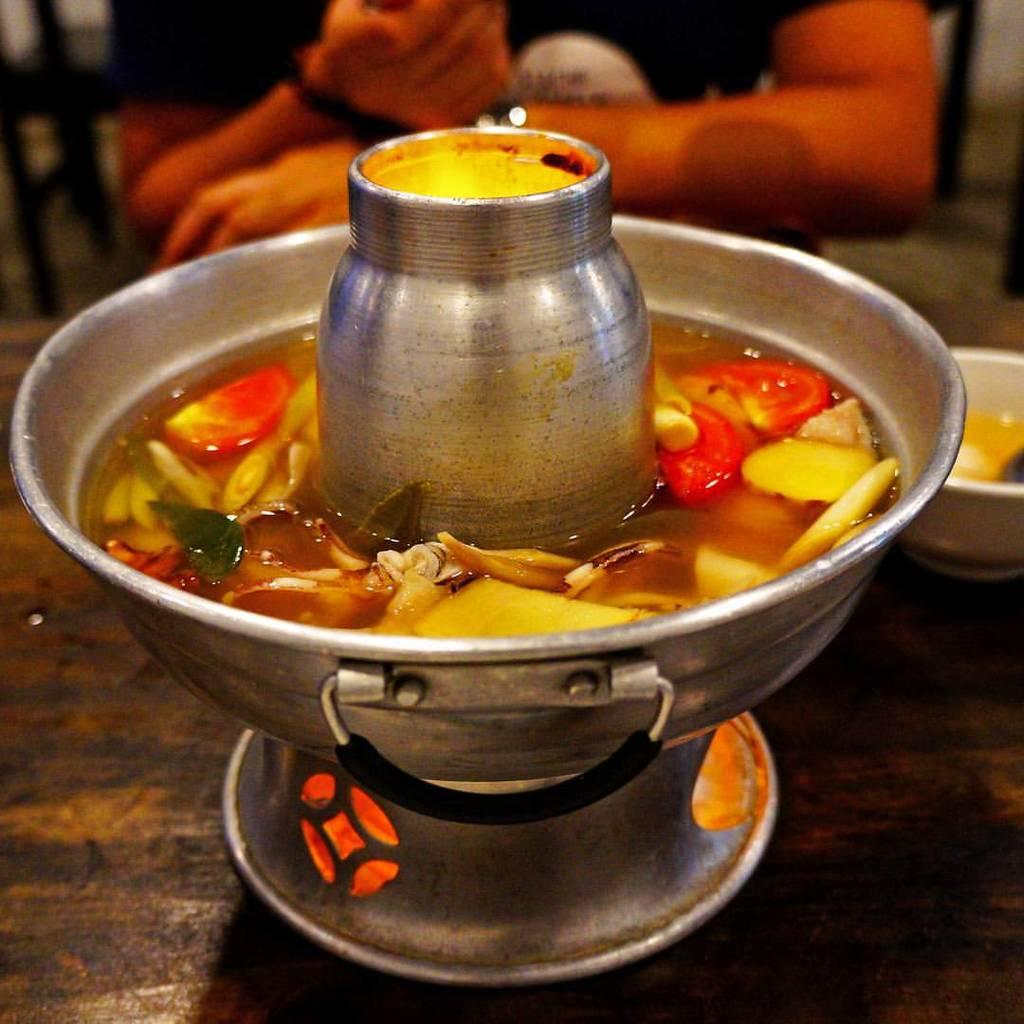What is the main object in the image? There is a hot pot in the image. Where is the hot pot located? The hot pot is on a table. What is inside the hot pot? There is a food item in the hot pot. How many quarters can be seen on the board in the image? There is no board or quarters present in the image; it features a hot pot on a table with a food item inside. 